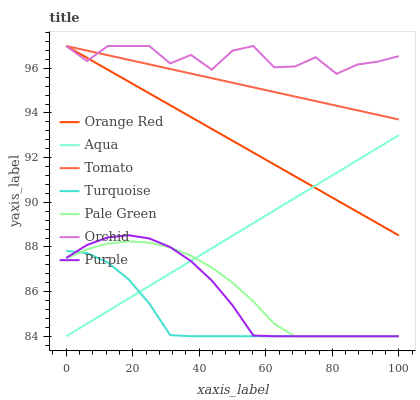Does Turquoise have the minimum area under the curve?
Answer yes or no. Yes. Does Orchid have the maximum area under the curve?
Answer yes or no. Yes. Does Purple have the minimum area under the curve?
Answer yes or no. No. Does Purple have the maximum area under the curve?
Answer yes or no. No. Is Tomato the smoothest?
Answer yes or no. Yes. Is Orchid the roughest?
Answer yes or no. Yes. Is Turquoise the smoothest?
Answer yes or no. No. Is Turquoise the roughest?
Answer yes or no. No. Does Orange Red have the lowest value?
Answer yes or no. No. Does Purple have the highest value?
Answer yes or no. No. Is Turquoise less than Tomato?
Answer yes or no. Yes. Is Orchid greater than Purple?
Answer yes or no. Yes. Does Turquoise intersect Tomato?
Answer yes or no. No. 